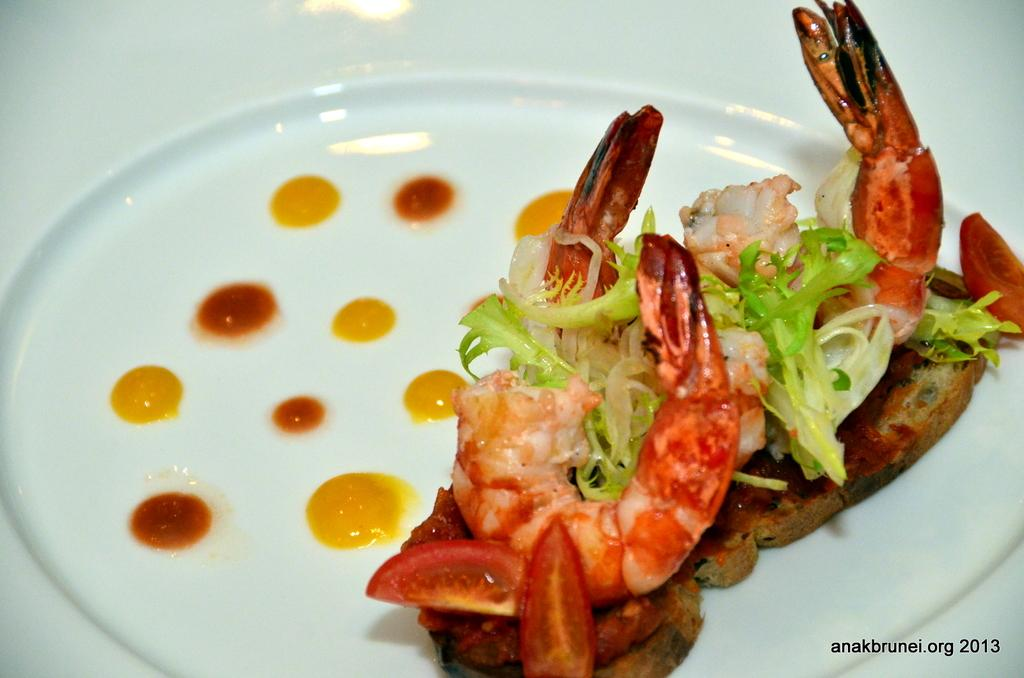What is on the plate that is visible in the image? There is food in a plate in the image. Where is the plate located in the image? The plate is on a platform in the image. What can be seen at the bottom of the image? There is text or writing at the bottom of the image. What is the value of the yam in the image? There is no yam present in the image, so it is not possible to determine its value. 